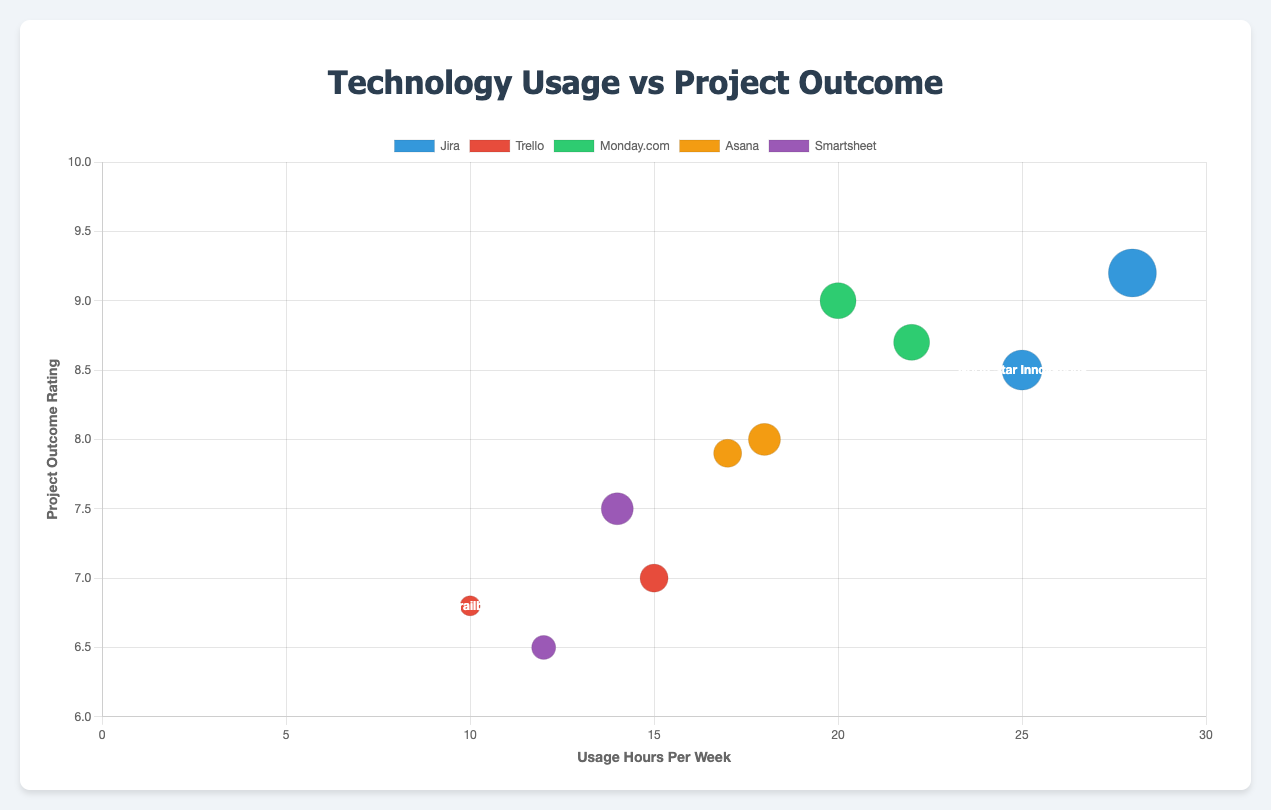What is the title of the chart? The title is displayed prominently at the top of the chart. It reads "Technology Usage vs Project Outcome".
Answer: Technology Usage vs Project Outcome Which technology was used by North Star Innovations, and what was their project outcome rating? The tooltip or legend can provide this information. North Star Innovations used Jira and had a project outcome rating of 8.5.
Answer: Jira, 8.5 How many teams used Monday.com, and what is the average project outcome rating for these teams? From the legend and datasets, there are two teams (GreenTech Developers and Future Forward) using Monday.com. Their project ratings are 9.0 and 8.7, respectively. The average rating is (9.0 + 8.7) / 2 = 8.85.
Answer: 2 teams, 8.85 Which team had the highest project outcome rating and what technology did they use? By looking at the y-axis values and the size of the circles, Innovation Architects had the highest rating of 9.2 and used Jira.
Answer: Innovation Architects, Jira Which team spent the most hours per week using their technology, and how many hours was it? The x-axis values show that Innovation Architects had the highest usage hours per week at 28 hours.
Answer: Innovation Architects, 28 hours Compare the project outcome ratings between the teams using Asana. Which team had a higher rating and by how much? The two teams using Asana are Cyber Dynamics (8.0) and SkyNet Solutions (7.9). The difference in their ratings is 8.0 - 7.9 = 0.1.
Answer: Cyber Dynamics, 0.1 What is the average number of team members across all teams? The bubble size represents the number of team members. Sum the team members (10 + 7 + 9 + 8 + 6 + 12 + 5 + 9 + 7 + 8) = 81, and there are ten teams. The average is 81 / 10 = 8.1.
Answer: 8.1 Which team using Smartsheet has a lower project outcome rating, and what is their rating? By inspecting the two teams using Smartsheet, Digital Pioneers (6.5) and Nova Techies (7.5), Digital Pioneers has the lower rating of 6.5.
Answer: Digital Pioneers, 6.5 How many teams have a project outcome rating of 8.0 or higher? By counting the number of bubbles with y-axis values 8.0 or higher: North Star Innovations, GreenTech Developers, Cyber Dynamics, Innovation Architects, Future Forward, and SkyNet Solutions. That's 6 teams.
Answer: 6 teams What is the correlation between technology usage hours and project outcome ratings evident in the chart? Observing the chart, it appears that higher usage hours generally correlate with higher project outcome ratings, though there are exceptions (like Tech Trailblazers).
Answer: Positive correlation 